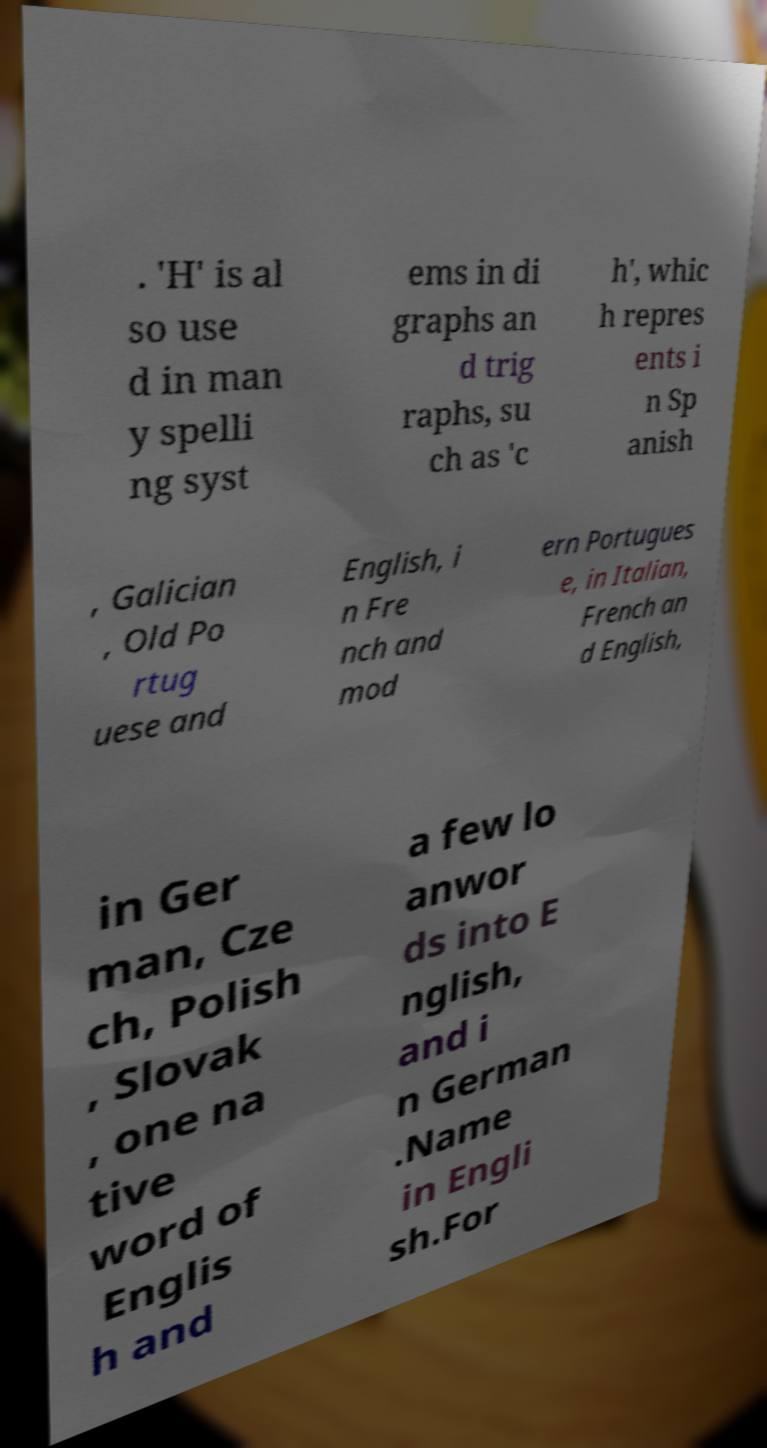For documentation purposes, I need the text within this image transcribed. Could you provide that? . 'H' is al so use d in man y spelli ng syst ems in di graphs an d trig raphs, su ch as 'c h', whic h repres ents i n Sp anish , Galician , Old Po rtug uese and English, i n Fre nch and mod ern Portugues e, in Italian, French an d English, in Ger man, Cze ch, Polish , Slovak , one na tive word of Englis h and a few lo anwor ds into E nglish, and i n German .Name in Engli sh.For 